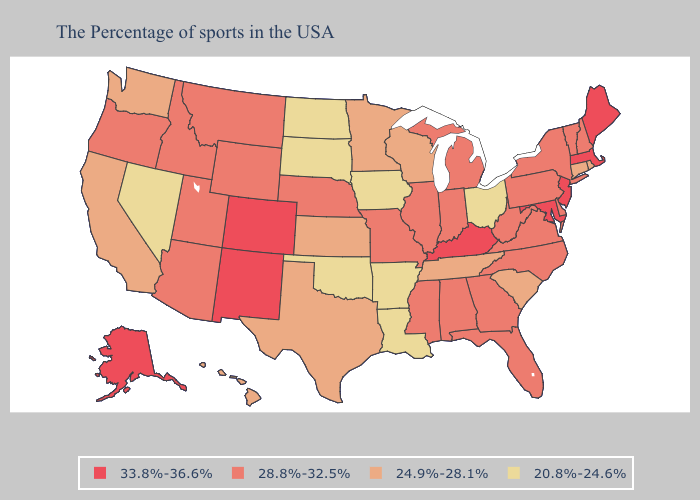What is the highest value in states that border Alabama?
Concise answer only. 28.8%-32.5%. Does Texas have the highest value in the USA?
Concise answer only. No. Name the states that have a value in the range 20.8%-24.6%?
Concise answer only. Ohio, Louisiana, Arkansas, Iowa, Oklahoma, South Dakota, North Dakota, Nevada. What is the highest value in the South ?
Quick response, please. 33.8%-36.6%. Name the states that have a value in the range 33.8%-36.6%?
Short answer required. Maine, Massachusetts, New Jersey, Maryland, Kentucky, Colorado, New Mexico, Alaska. Which states have the highest value in the USA?
Give a very brief answer. Maine, Massachusetts, New Jersey, Maryland, Kentucky, Colorado, New Mexico, Alaska. Among the states that border Virginia , which have the highest value?
Quick response, please. Maryland, Kentucky. Does the first symbol in the legend represent the smallest category?
Keep it brief. No. Which states have the lowest value in the USA?
Write a very short answer. Ohio, Louisiana, Arkansas, Iowa, Oklahoma, South Dakota, North Dakota, Nevada. Does Nebraska have the highest value in the MidWest?
Write a very short answer. Yes. What is the highest value in states that border Virginia?
Short answer required. 33.8%-36.6%. What is the lowest value in states that border South Carolina?
Be succinct. 28.8%-32.5%. Does Vermont have the highest value in the Northeast?
Give a very brief answer. No. Name the states that have a value in the range 33.8%-36.6%?
Concise answer only. Maine, Massachusetts, New Jersey, Maryland, Kentucky, Colorado, New Mexico, Alaska. 